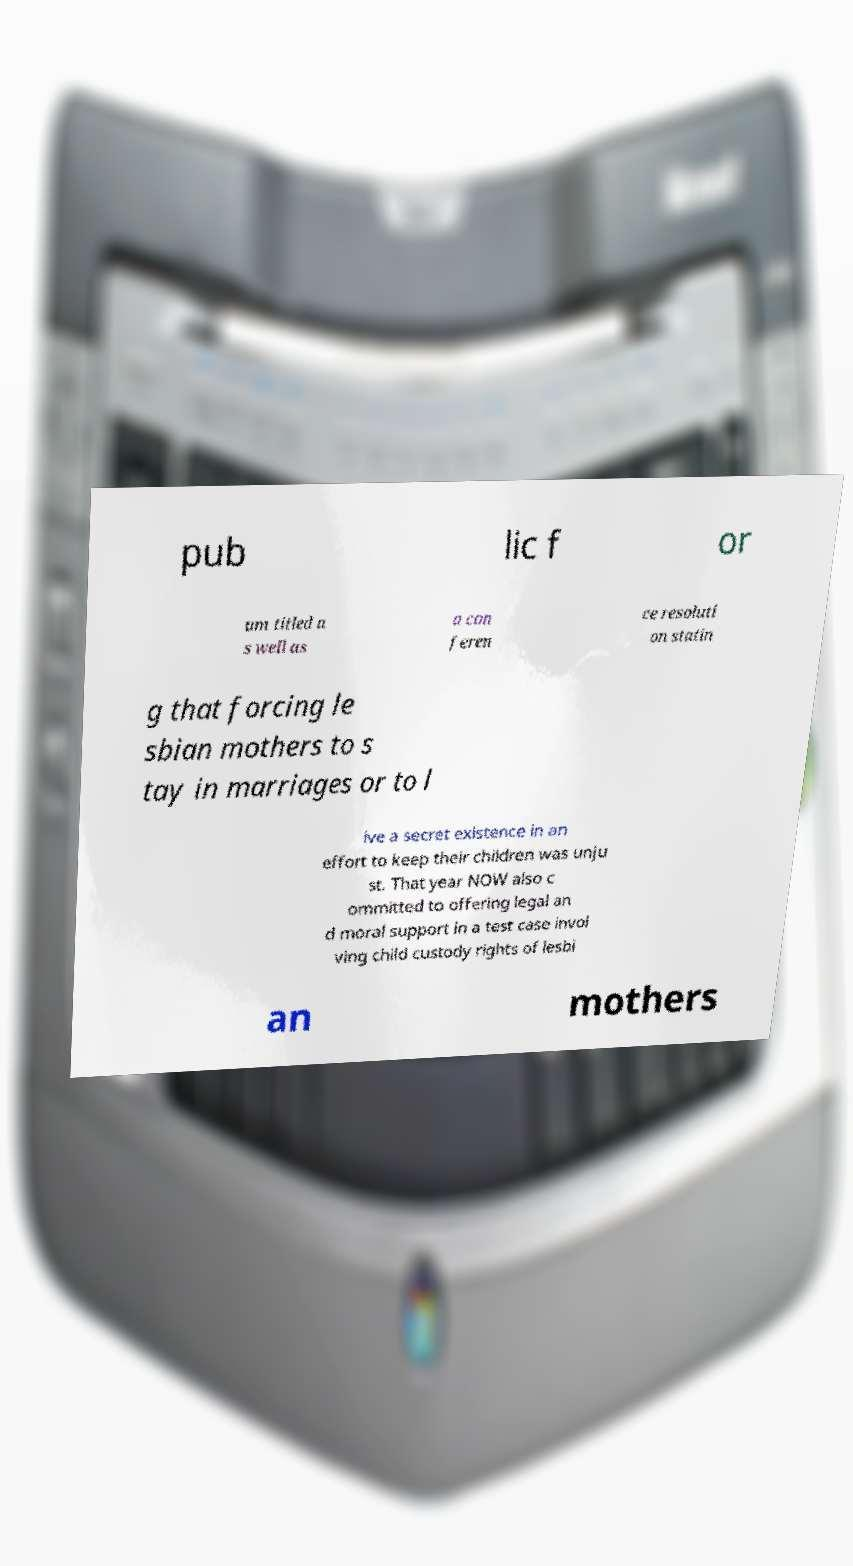Could you extract and type out the text from this image? pub lic f or um titled a s well as a con feren ce resoluti on statin g that forcing le sbian mothers to s tay in marriages or to l ive a secret existence in an effort to keep their children was unju st. That year NOW also c ommitted to offering legal an d moral support in a test case invol ving child custody rights of lesbi an mothers 